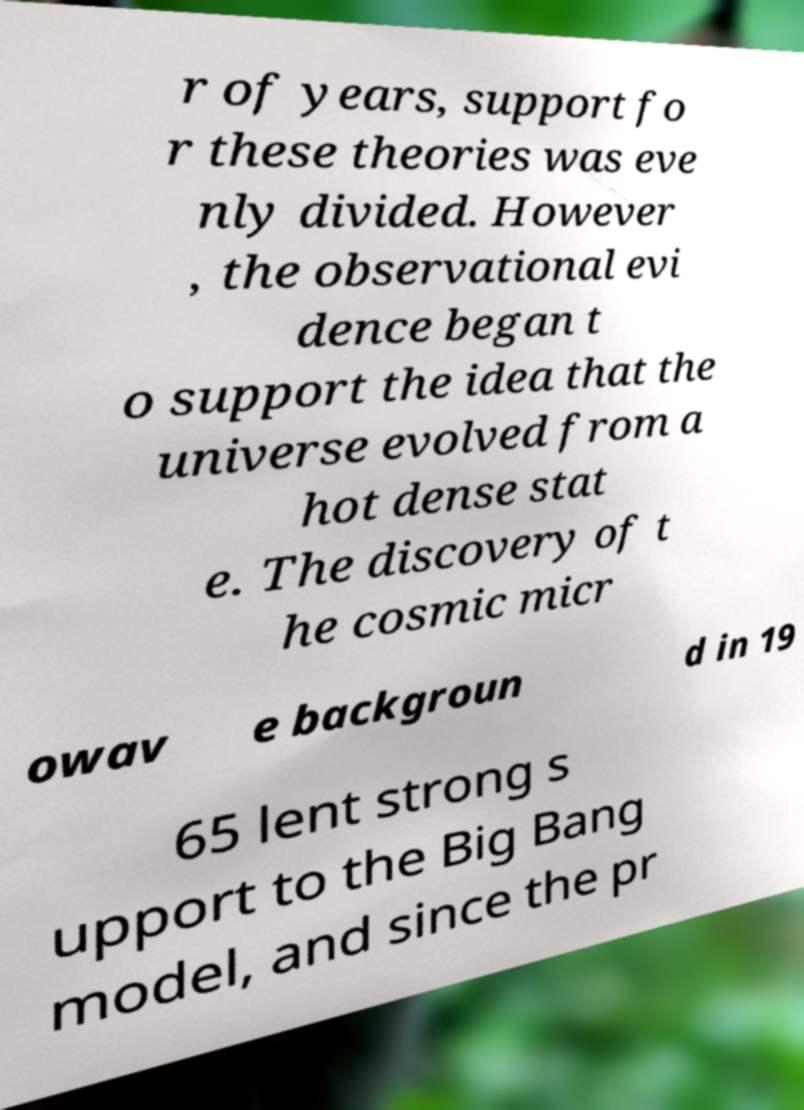Can you accurately transcribe the text from the provided image for me? r of years, support fo r these theories was eve nly divided. However , the observational evi dence began t o support the idea that the universe evolved from a hot dense stat e. The discovery of t he cosmic micr owav e backgroun d in 19 65 lent strong s upport to the Big Bang model, and since the pr 